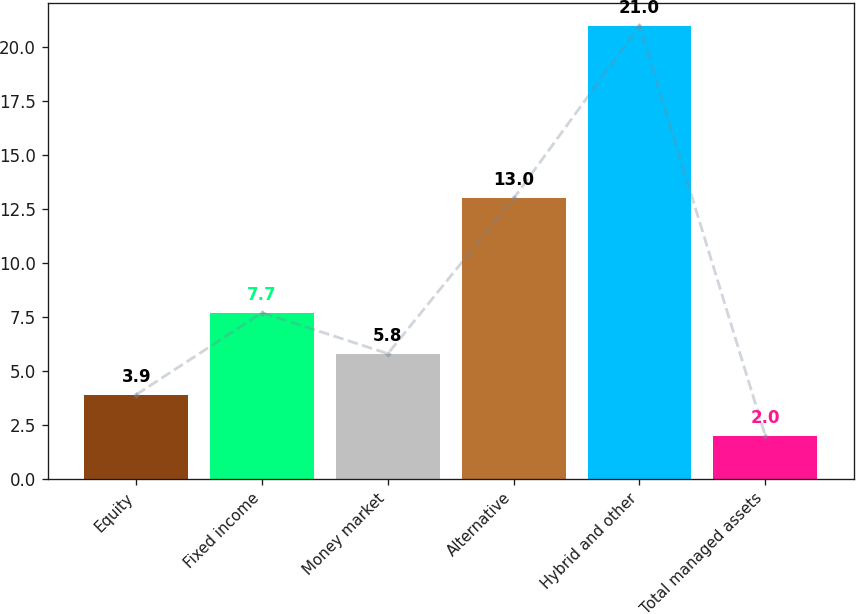Convert chart. <chart><loc_0><loc_0><loc_500><loc_500><bar_chart><fcel>Equity<fcel>Fixed income<fcel>Money market<fcel>Alternative<fcel>Hybrid and other<fcel>Total managed assets<nl><fcel>3.9<fcel>7.7<fcel>5.8<fcel>13<fcel>21<fcel>2<nl></chart> 